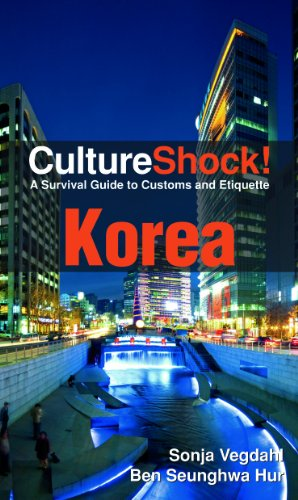What type of book is this? This book is a travel and cultural guide, specifically designed to help readers navigate the complexities and nuances of Korean customs and etiquettes effectively. 